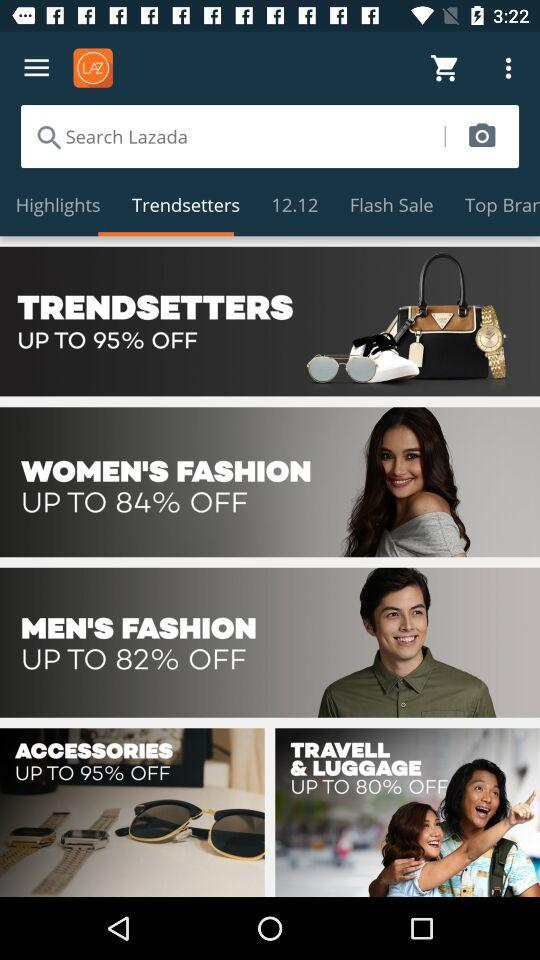How many navigation items are on the screen?
Answer the question using a single word or phrase. 5 